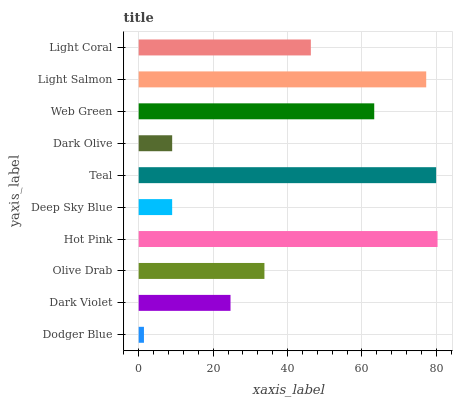Is Dodger Blue the minimum?
Answer yes or no. Yes. Is Hot Pink the maximum?
Answer yes or no. Yes. Is Dark Violet the minimum?
Answer yes or no. No. Is Dark Violet the maximum?
Answer yes or no. No. Is Dark Violet greater than Dodger Blue?
Answer yes or no. Yes. Is Dodger Blue less than Dark Violet?
Answer yes or no. Yes. Is Dodger Blue greater than Dark Violet?
Answer yes or no. No. Is Dark Violet less than Dodger Blue?
Answer yes or no. No. Is Light Coral the high median?
Answer yes or no. Yes. Is Olive Drab the low median?
Answer yes or no. Yes. Is Olive Drab the high median?
Answer yes or no. No. Is Teal the low median?
Answer yes or no. No. 